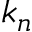<formula> <loc_0><loc_0><loc_500><loc_500>k _ { n }</formula> 